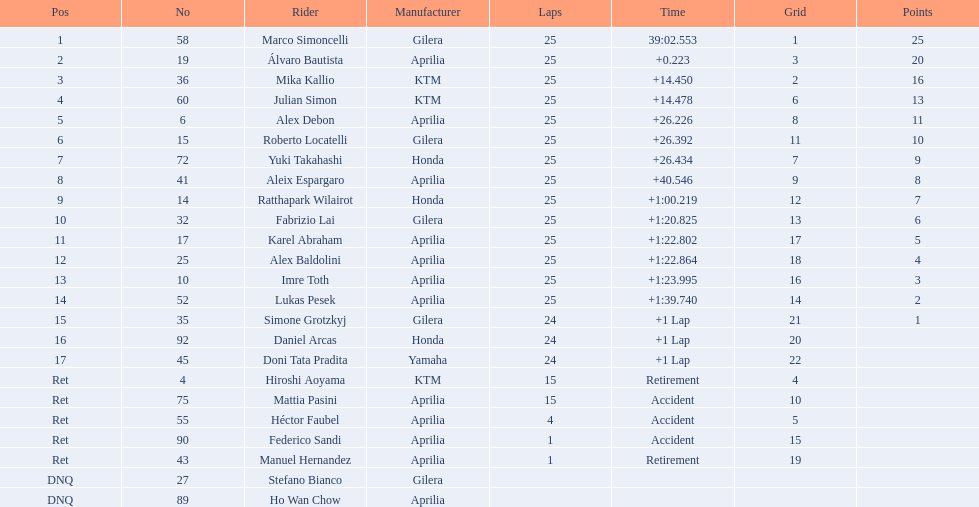The country with the most riders was Italy. 